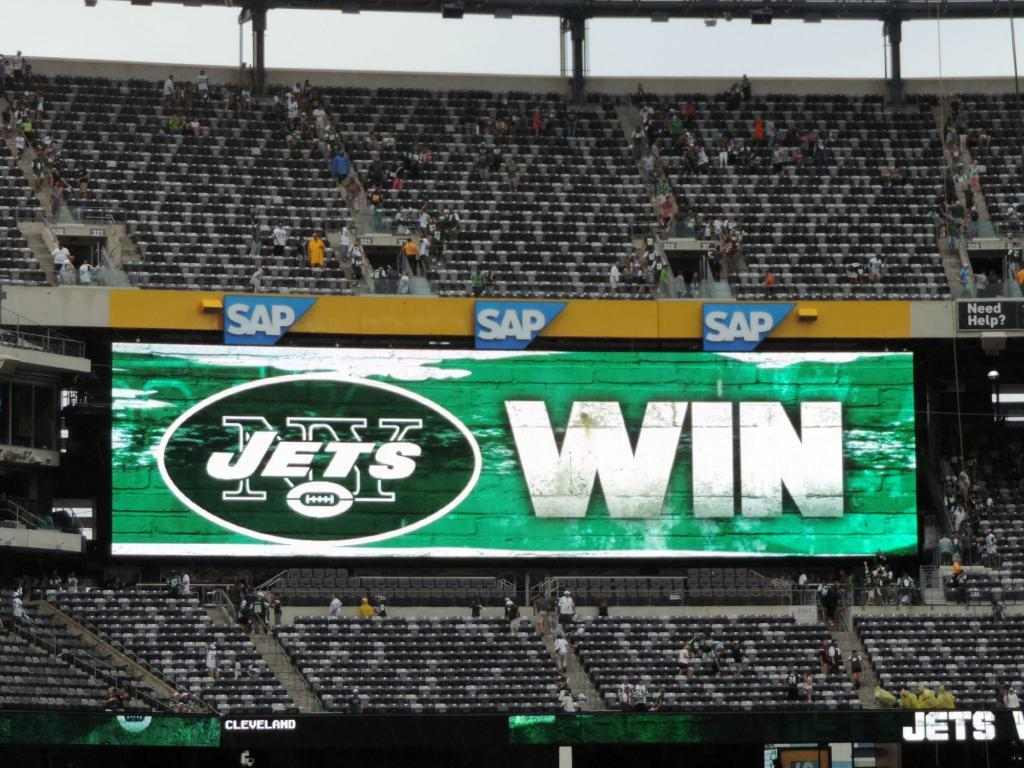What type of location is depicted in the image? The image is of a stadium. What type of seating is available in the stadium? There are chairs in the stadium. What other structures can be seen in the stadium? There are poles, hoardings, steps, and a screen in the stadium. Are there any people present in the image? Yes, there are people standing in the stadium. What is visible in the background of the image? The sky is visible in the image. Where is the cabbage located in the image? There is no cabbage present in the image. What type of desk can be seen in the image? There is no desk present in the image. 